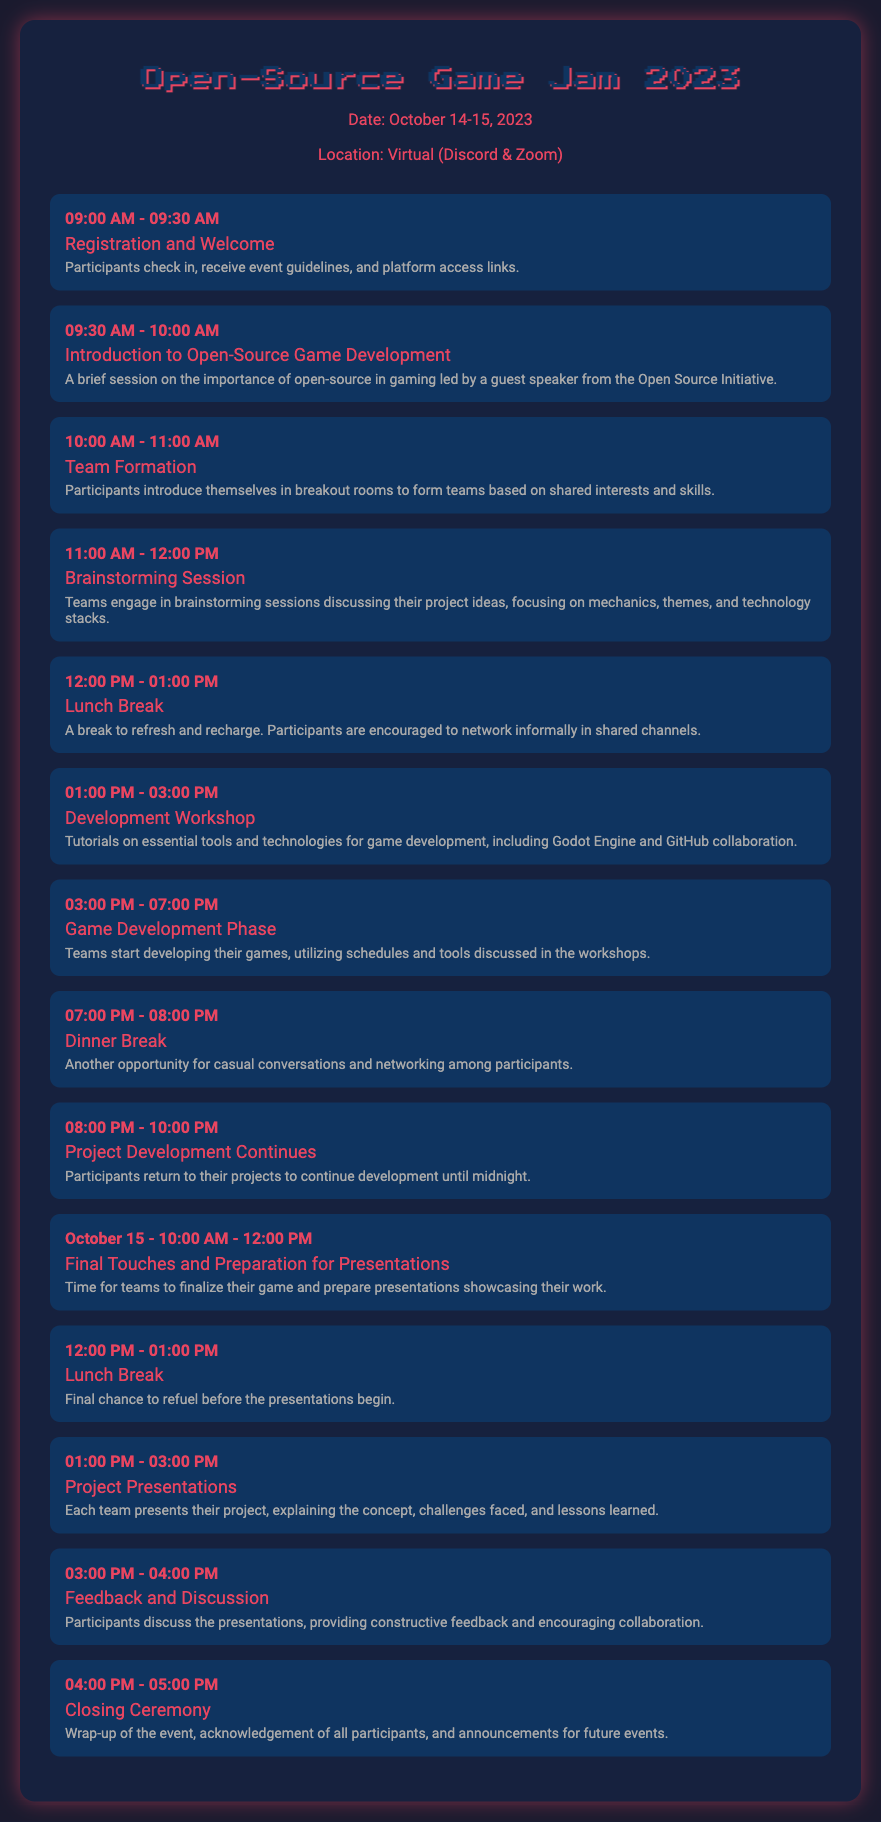What is the date of the event? The date is specified in the document as October 14-15, 2023.
Answer: October 14-15, 2023 What activity starts at 9:30 AM? The activity listed at this time slot is "Introduction to Open-Source Game Development."
Answer: Introduction to Open-Source Game Development How long is the Game Development Phase? The duration for the Game Development Phase is indicated in the agenda from 3:00 PM to 7:00 PM, totaling 4 hours.
Answer: 4 hours What is the focus of the brainstorming session? The details mention that teams will discuss project ideas, mechanics, themes, and technology stacks, indicating the session's focus areas.
Answer: Project ideas, mechanics, themes, technology stacks What is the last activity of the event? The final activity listed in the agenda is "Closing Ceremony."
Answer: Closing Ceremony How many lunch breaks are scheduled? There are two lunch breaks mentioned in the agenda: one on October 14 and a second on October 15.
Answer: 2 What time do project presentations start? The project presentations are scheduled to begin at 1:00 PM on October 15.
Answer: 1:00 PM How long is the feedback discussion after the project presentations? The feedback and discussion session is set for 1 hour, from 3:00 PM to 4:00 PM.
Answer: 1 hour 